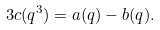Convert formula to latex. <formula><loc_0><loc_0><loc_500><loc_500>3 c ( q ^ { 3 } ) = a ( q ) - b ( q ) .</formula> 